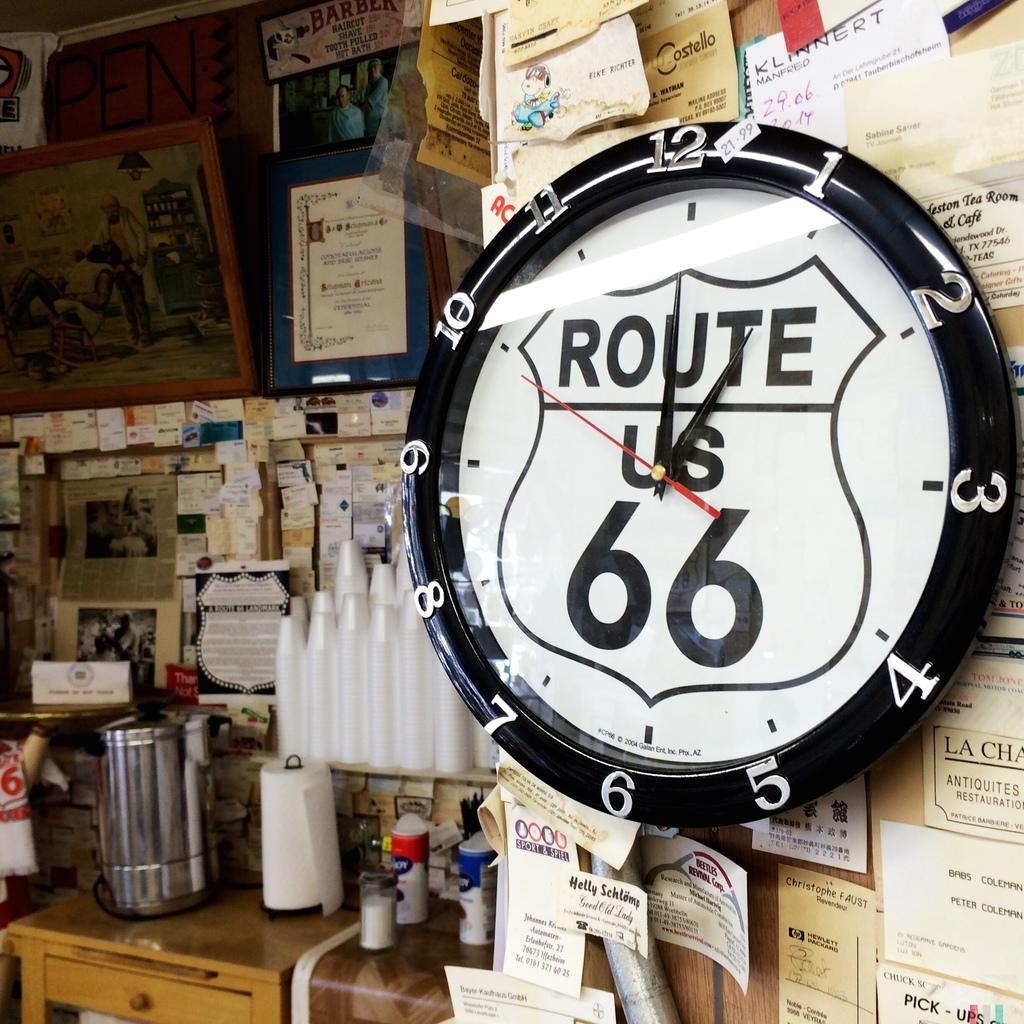<image>
Provide a brief description of the given image. A white clock says Route US 66 and is on a wall with notes all over it. 